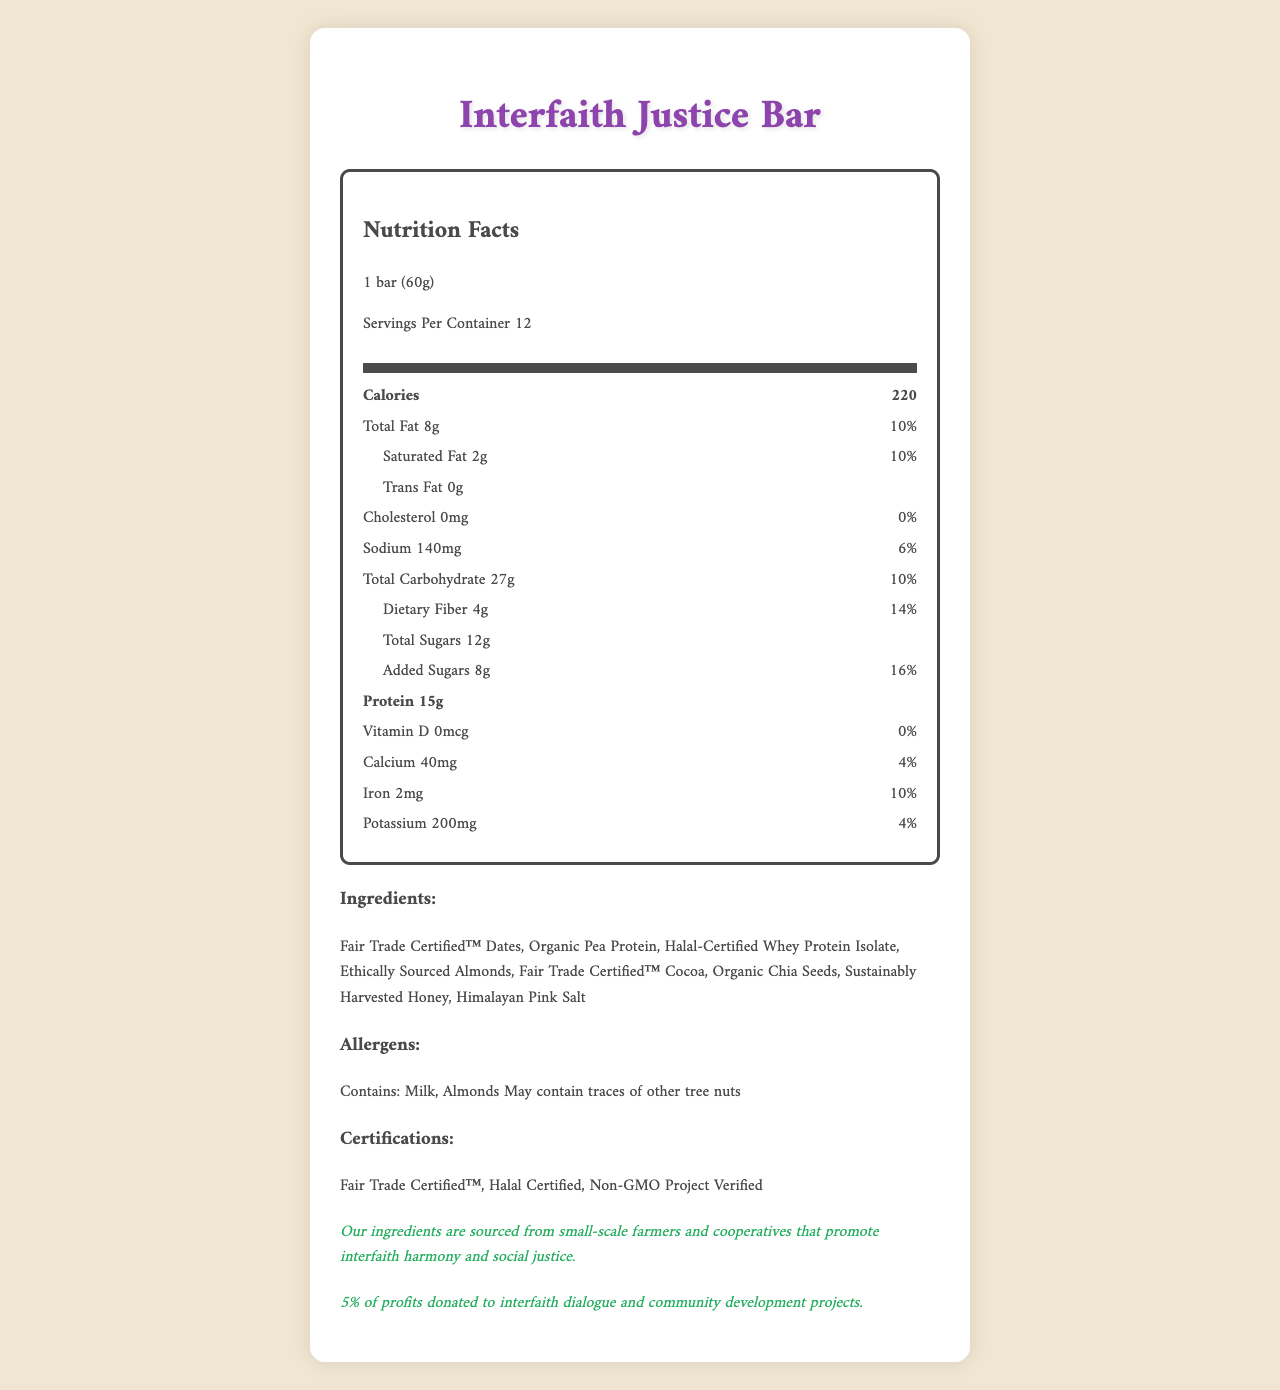what is the product name? The product name is listed at the top of the document and in the title.
Answer: Interfaith Justice Bar what is the serving size of the Interfaith Justice Bar? The serving size is clearly mentioned at the top of the nutrition facts section.
Answer: 1 bar (60g) how many servings are there per container? The servings per container information is provided under the serving size and servings per container section.
Answer: 12 how much protein does one bar contain? The amount of protein per serving is given in the nutrition facts label.
Answer: 15g what is the total amount of saturated fat in one bar? The saturated fat amount is specified under the total fat section.
Answer: 2g how much dietary fiber is present in one serving? The dietary fiber content is mentioned under the total carbohydrate section.
Answer: 4g which vitamins or minerals have a daily value percentage listed? The daily value percentages are listed next to calcium, iron, and potassium amounts in the nutrition facts.
Answer: Calcium (4%), Iron (10%), Potassium (4%) what certifications does the Interfaith Justice Bar have? A. USDA Organic B. Halal Certified C. Gluten-Free D. Vegan The certifications listed include Halal Certified, Fair Trade Certified™, and Non-GMO Project Verified.
Answer: B what allergens are present in the Interfaith Justice Bar? A. Milk, Almonds B. Soy, Peanuts C. Wheat, Eggs D. Fish, Shellfish The allergens stated are Milk and Almonds, with a possibility of traces of other tree nuts.
Answer: A does the Interfaith Justice Bar contain any trans fat? The nutrition facts label indicates 0g trans fat.
Answer: No is the Interfaith Justice Bar's sourcing statement focused on interfaith harmony? The statement specifically mentions sourcing from small-scale farmers and cooperatives that promote interfaith harmony and social justice.
Answer: Yes can we determine the sugar content in the bar? The total sugars content is provided as 12g, with 8g as added sugars.
Answer: Yes what percentage of profits is donated to community development projects? The social impact statement mentions that 5% of profits are donated to interfaith dialogue and community development projects.
Answer: 5% what are some of the main ingredients in the Interfaith Justice Bar? The ingredients list includes Fair Trade Certified™ Dates, Organic Pea Protein, Halal-Certified Whey Protein Isolate, among others.
Answer: Examples include Fair Trade Certified™ Dates, Organic Pea Protein, Halal-Certified Whey Protein Isolate. how many calories are in one serving of the Interfaith Justice Bar? The calorie content is clearly provided in the nutrition facts label.
Answer: 220 how many ingredients are Fair Trade Certified™? The document lists Fair Trade Certified™ Dates and Fair Trade Certified™ Cocoa as ingredients.
Answer: Two summarize the main nutritional and ethical aspects of the Interfaith Justice Bar. The bar is nutritionally balanced with a focus on protein and dietary fiber. It supports ethical sourcing and fair trade, emphasizing interfaith harmony and community development through profit donations.
Answer: The Interfaith Justice Bar contains 220 calories per serving, with 15g of protein and 4g of dietary fiber. It is Halal Certified, Non-GMO, and contains fair trade and ethically sourced ingredients, donating 5% of profits to interfaith and community projects. what is the percentage of daily value for total fat? The daily value percentage for total fat is listed as 10%.
Answer: 10% what type of organic seeds are included in the Interfaith Justice Bar? The ingredients list mentions Organic Chia Seeds.
Answer: Organic Chia Seeds how much sodium does one bar contain? The sodium content in one bar is listed in the nutrition facts.
Answer: 140mg what is the primary objective stated for sourcing the bar's ingredients? A. Profit maximization B. Interfaith harmony and social justice C. High productivity D. Technological advancement The ethical sourcing statement specifies interfaith harmony and social justice as the primary objective.
Answer: B are there any details about the nutrient value of Vitamin B12? The document does not provide any information about Vitamin B12.
Answer: Cannot be determined 